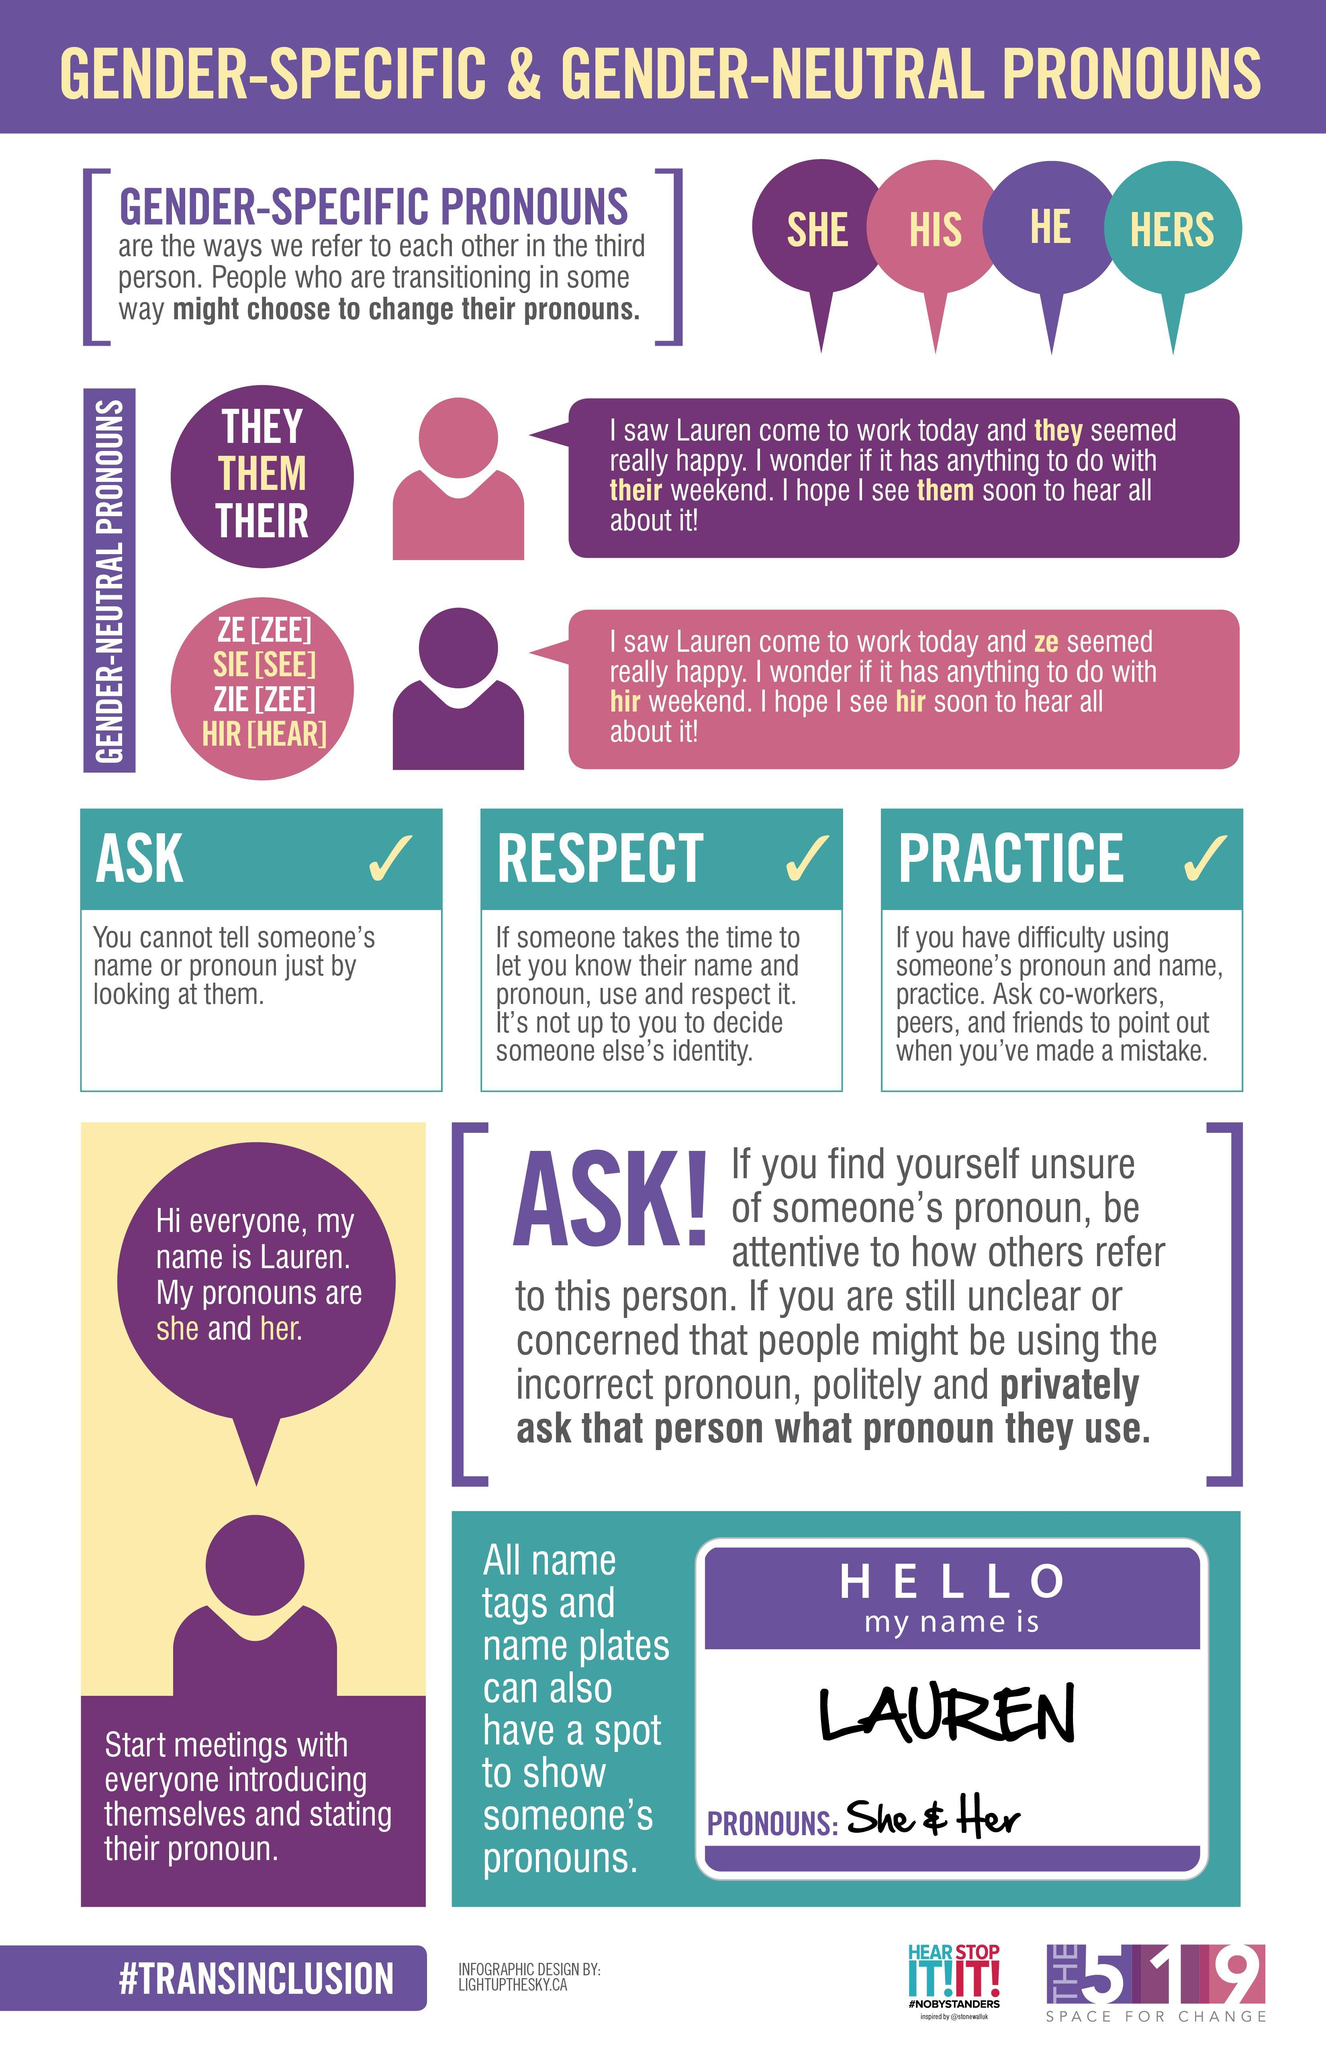what are the gender neutral pronouns shown in the purple circle
Answer the question with a short phrase. they, them, their what are the pronouns shown in the name tag She & Her Other than she, what other gender-specific pronouns his, he, hers 